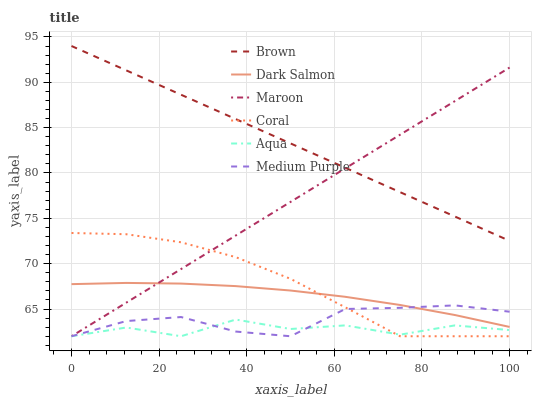Does Aqua have the minimum area under the curve?
Answer yes or no. Yes. Does Brown have the maximum area under the curve?
Answer yes or no. Yes. Does Coral have the minimum area under the curve?
Answer yes or no. No. Does Coral have the maximum area under the curve?
Answer yes or no. No. Is Brown the smoothest?
Answer yes or no. Yes. Is Aqua the roughest?
Answer yes or no. Yes. Is Coral the smoothest?
Answer yes or no. No. Is Coral the roughest?
Answer yes or no. No. Does Dark Salmon have the lowest value?
Answer yes or no. No. Does Brown have the highest value?
Answer yes or no. Yes. Does Coral have the highest value?
Answer yes or no. No. Is Aqua less than Brown?
Answer yes or no. Yes. Is Brown greater than Aqua?
Answer yes or no. Yes. Does Coral intersect Dark Salmon?
Answer yes or no. Yes. Is Coral less than Dark Salmon?
Answer yes or no. No. Is Coral greater than Dark Salmon?
Answer yes or no. No. Does Aqua intersect Brown?
Answer yes or no. No. 